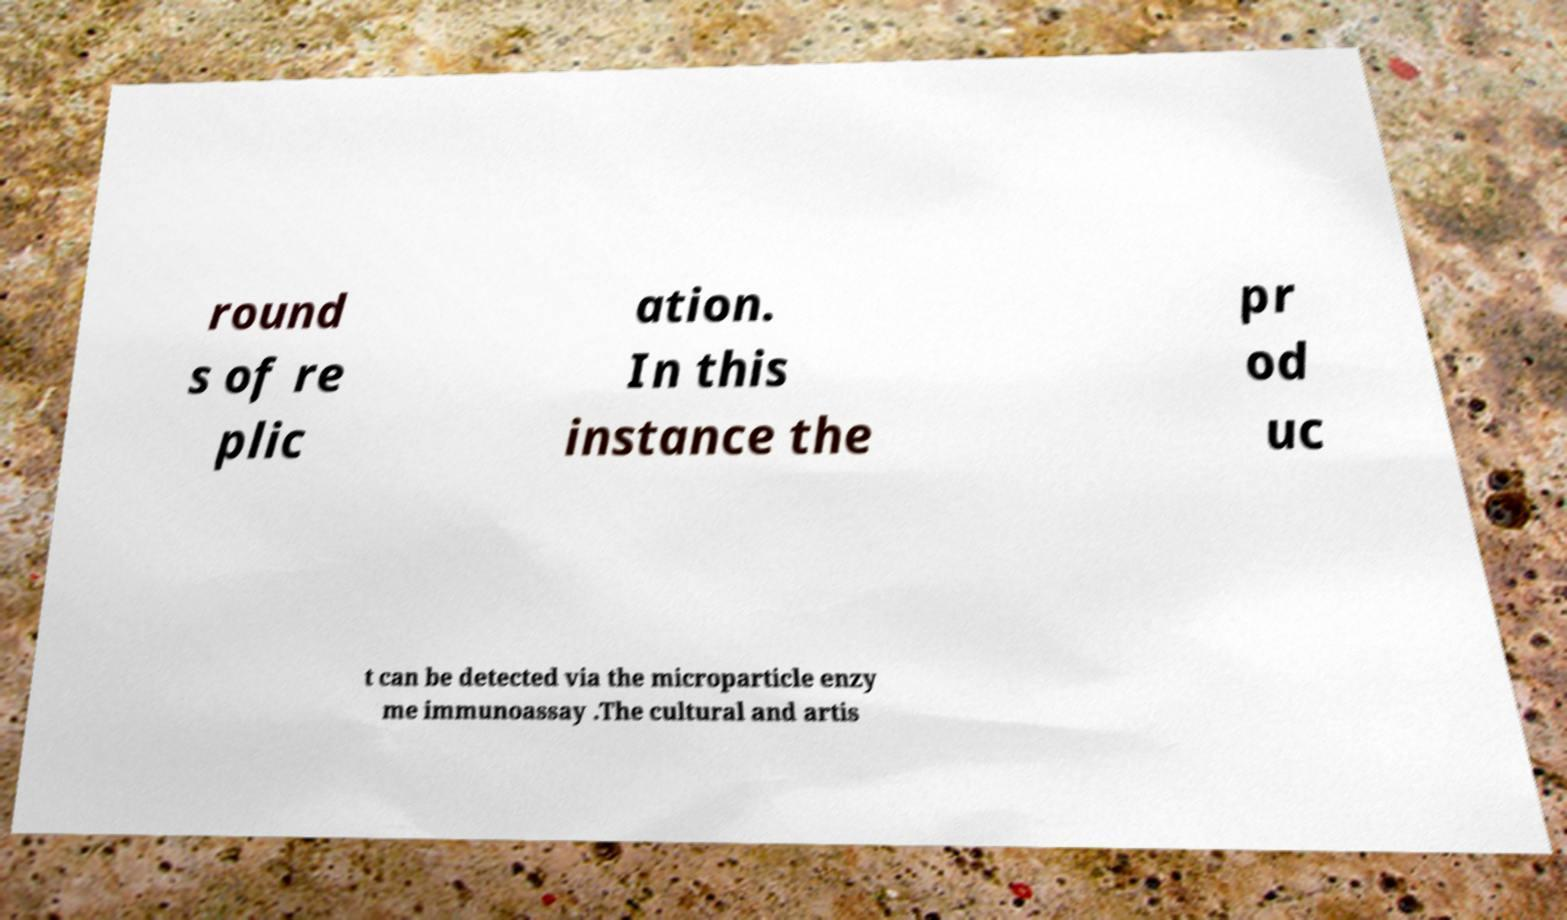Please identify and transcribe the text found in this image. round s of re plic ation. In this instance the pr od uc t can be detected via the microparticle enzy me immunoassay .The cultural and artis 